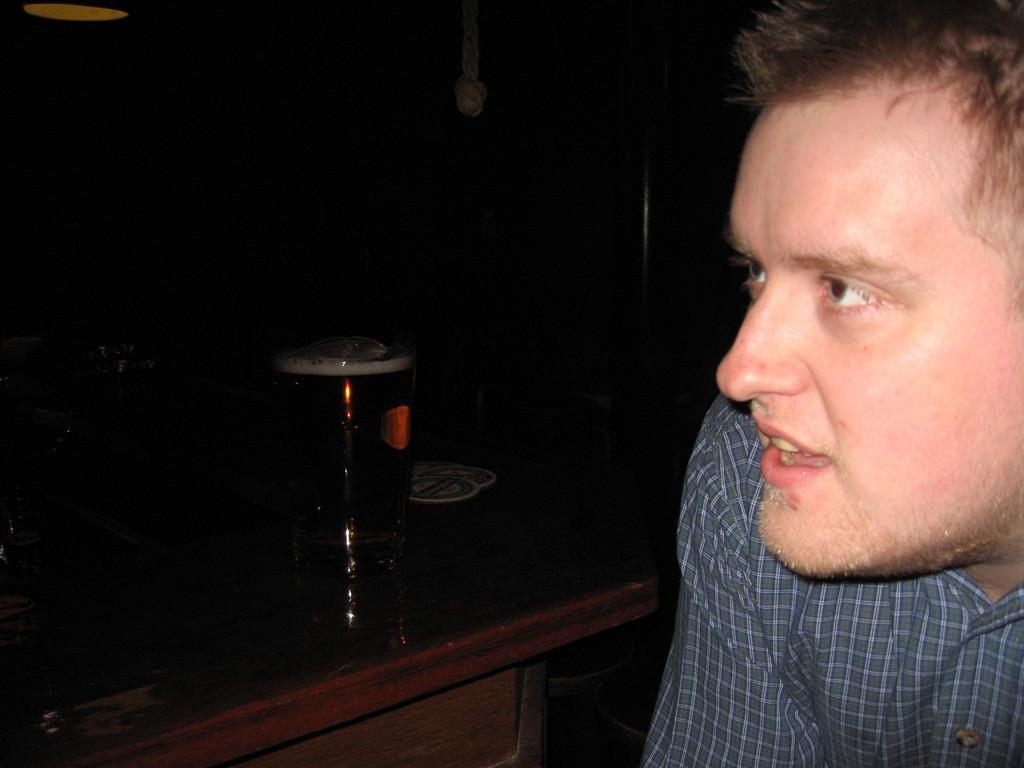Describe this image in one or two sentences. This is a picture of a man sitting on a chair to the left side of the man there is a table on the table there is a glass. Background of the man is in black color. 